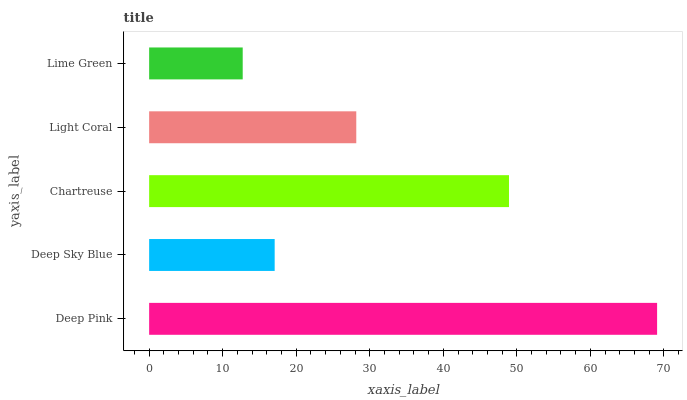Is Lime Green the minimum?
Answer yes or no. Yes. Is Deep Pink the maximum?
Answer yes or no. Yes. Is Deep Sky Blue the minimum?
Answer yes or no. No. Is Deep Sky Blue the maximum?
Answer yes or no. No. Is Deep Pink greater than Deep Sky Blue?
Answer yes or no. Yes. Is Deep Sky Blue less than Deep Pink?
Answer yes or no. Yes. Is Deep Sky Blue greater than Deep Pink?
Answer yes or no. No. Is Deep Pink less than Deep Sky Blue?
Answer yes or no. No. Is Light Coral the high median?
Answer yes or no. Yes. Is Light Coral the low median?
Answer yes or no. Yes. Is Deep Pink the high median?
Answer yes or no. No. Is Chartreuse the low median?
Answer yes or no. No. 